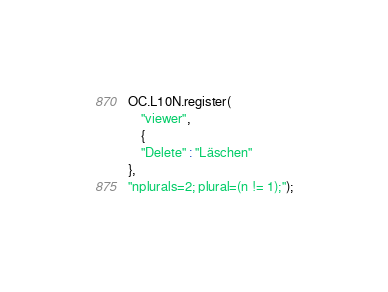Convert code to text. <code><loc_0><loc_0><loc_500><loc_500><_JavaScript_>OC.L10N.register(
    "viewer",
    {
    "Delete" : "Läschen"
},
"nplurals=2; plural=(n != 1);");
</code> 